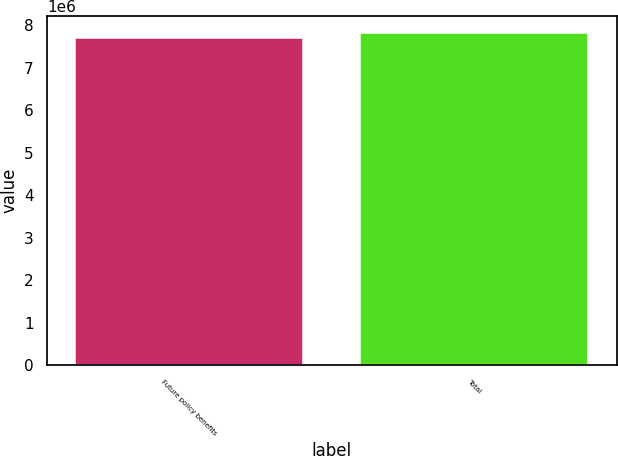<chart> <loc_0><loc_0><loc_500><loc_500><bar_chart><fcel>Future policy benefits<fcel>Total<nl><fcel>7.69711e+06<fcel>7.83281e+06<nl></chart> 